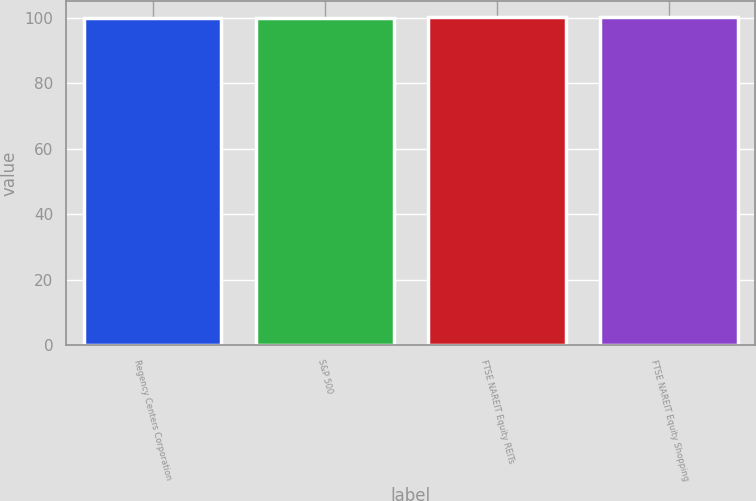Convert chart to OTSL. <chart><loc_0><loc_0><loc_500><loc_500><bar_chart><fcel>Regency Centers Corporation<fcel>S&P 500<fcel>FTSE NAREIT Equity REITs<fcel>FTSE NAREIT Equity Shopping<nl><fcel>100<fcel>100.1<fcel>100.2<fcel>100.3<nl></chart> 